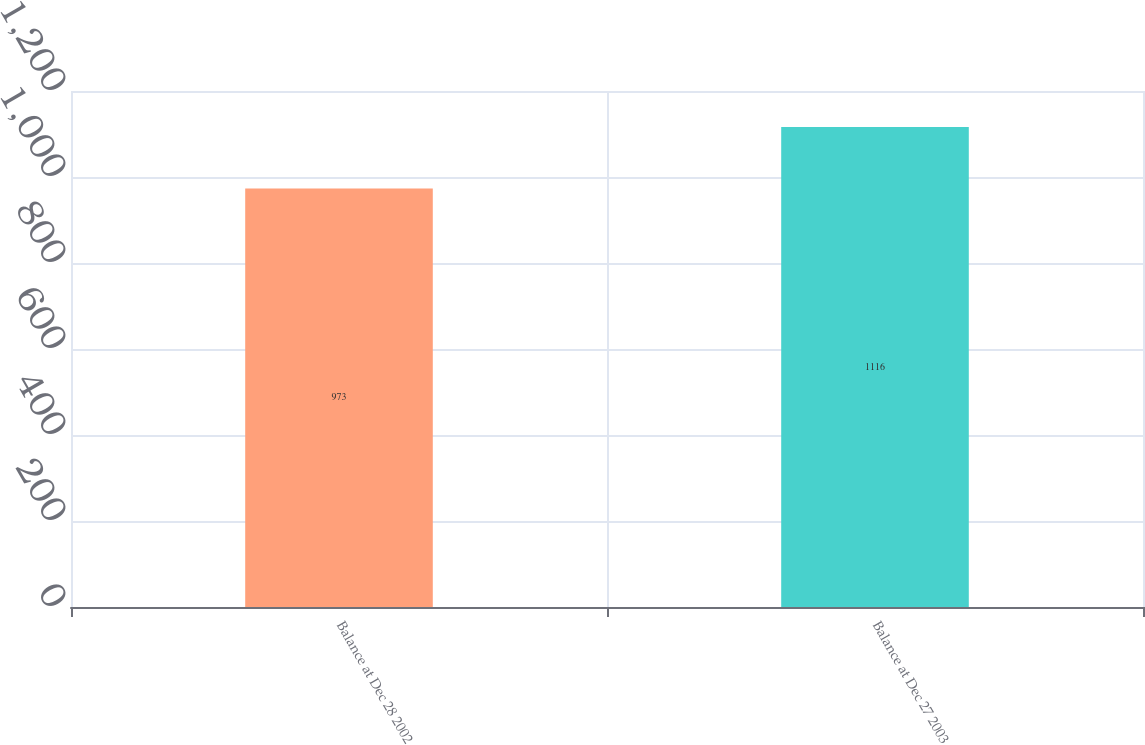Convert chart. <chart><loc_0><loc_0><loc_500><loc_500><bar_chart><fcel>Balance at Dec 28 2002<fcel>Balance at Dec 27 2003<nl><fcel>973<fcel>1116<nl></chart> 